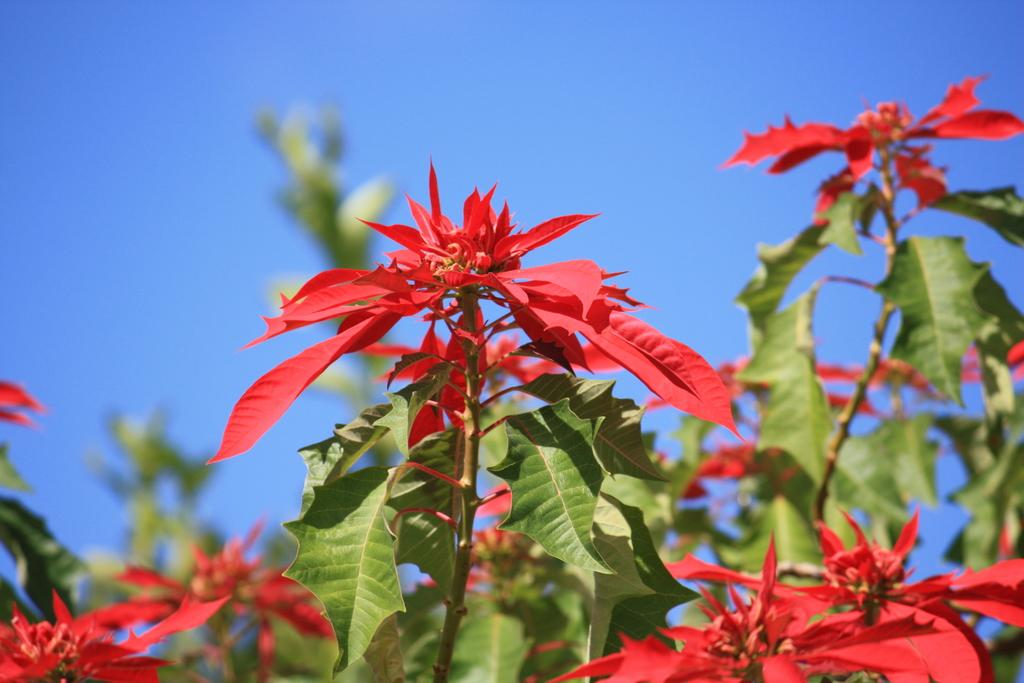Where was the image taken? The image is taken outdoors. What can be seen at the top of the image? The sky is visible at the top of the image. What type of vegetation is present in the image? There are plants with green leaves in the image. What color are the flowers on the plants? The plants have red flowers. What type of sail can be seen in the image? There is no sail present in the image. What kind of feast is being prepared in the image? There is no feast being prepared in the image; it features plants with red flowers. 